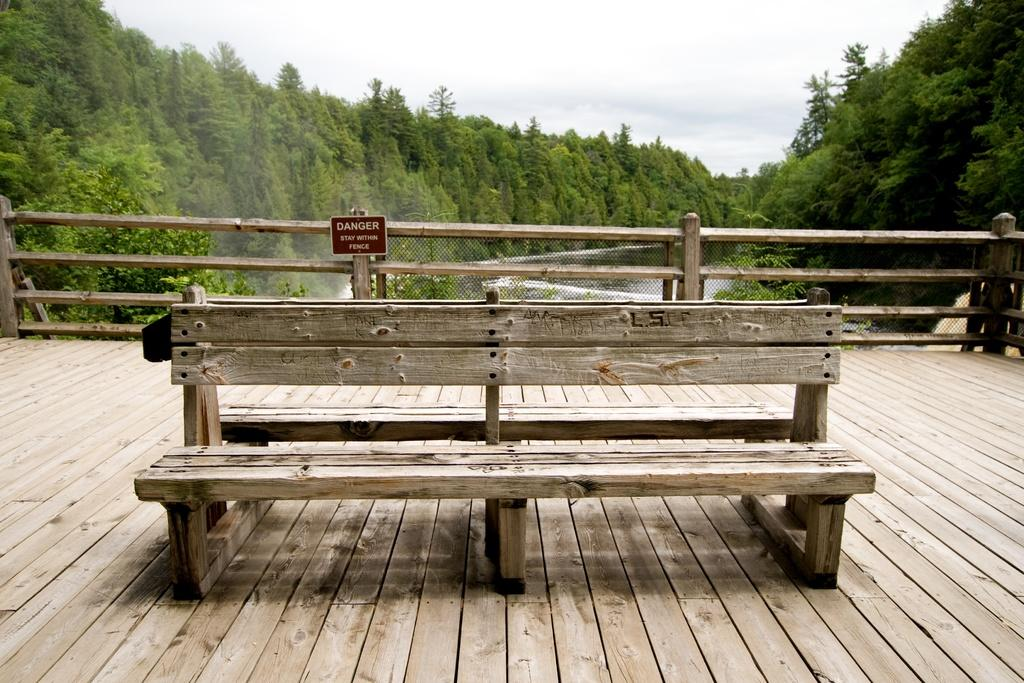What type of seating is visible in the image? There is a bench in the image. What is attached to the railing in the image? A signboard is attached to the railing. What can be seen in the background of the image? The background of the image includes the sky, trees, and water. What is the purpose of the railing in the image? The railing may provide safety or support for people using the bench. What type of yard is visible in the image? There is no yard present in the image. What suggestion does the signboard on the railing provide? The image does not show the content of the signboard, so we cannot determine any suggestions it may provide. 